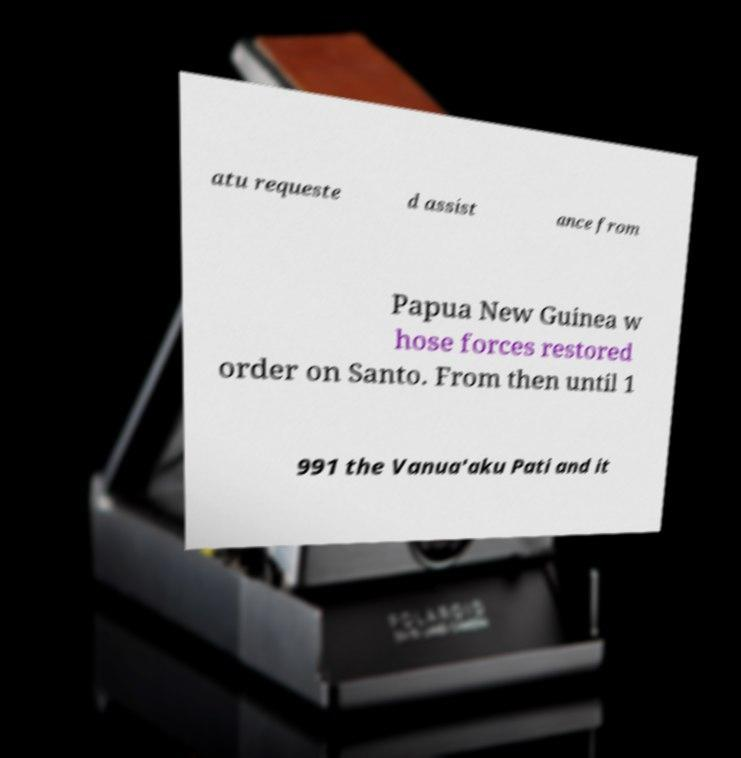For documentation purposes, I need the text within this image transcribed. Could you provide that? atu requeste d assist ance from Papua New Guinea w hose forces restored order on Santo. From then until 1 991 the Vanua'aku Pati and it 